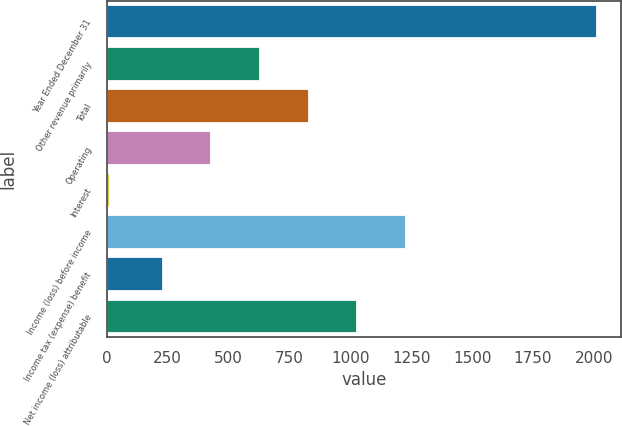Convert chart. <chart><loc_0><loc_0><loc_500><loc_500><bar_chart><fcel>Year Ended December 31<fcel>Other revenue primarily<fcel>Total<fcel>Operating<fcel>Interest<fcel>Income (loss) before income<fcel>Income tax (expense) benefit<fcel>Net income (loss) attributable<nl><fcel>2012<fcel>628.6<fcel>828.4<fcel>428.8<fcel>14<fcel>1228<fcel>229<fcel>1028.2<nl></chart> 